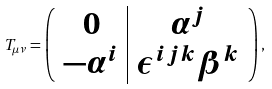<formula> <loc_0><loc_0><loc_500><loc_500>T _ { \mu \nu } = \left ( \begin{array} { c | c } 0 & \alpha ^ { j } \\ - \alpha ^ { i } & \epsilon ^ { i j k } \beta ^ { k } \\ \end{array} \right ) ,</formula> 